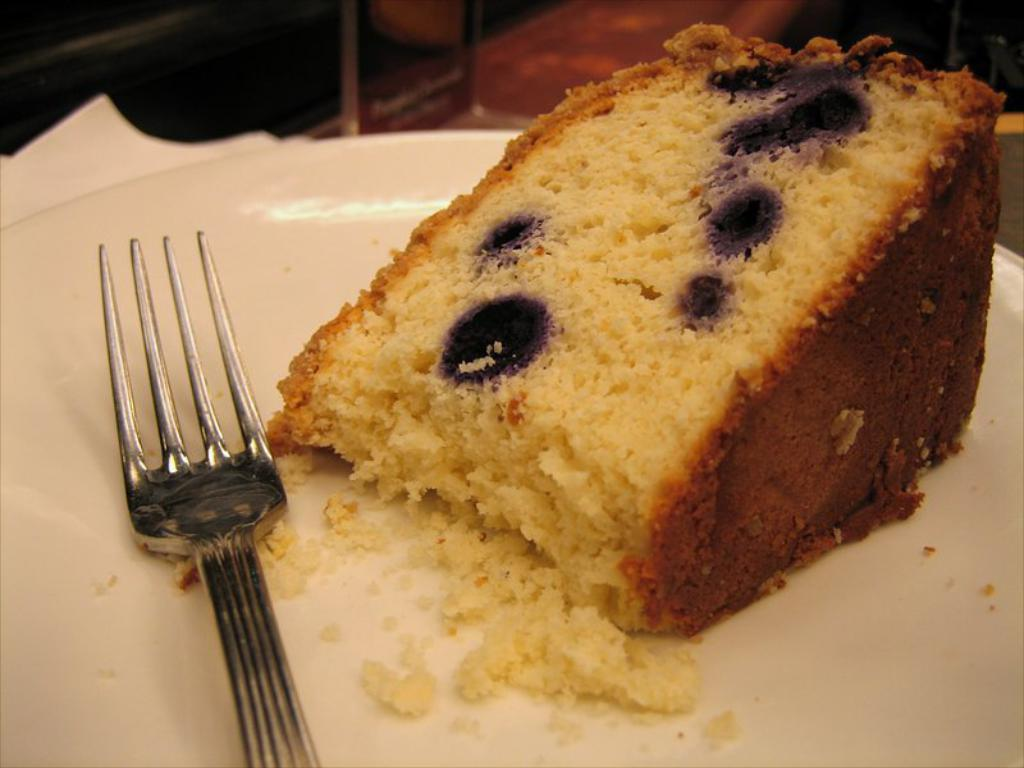What object is present on the plate in the image? There is a fork on the plate in the image. What else can be seen on the plate besides the fork? There is food on the plate in the image. What is the color of the plate? The plate is white. What can be seen behind the plate in the image? There are items visible behind the plate in the image. How many pins are holding the food on the plate in the image? There are no pins present in the image; the food is held on the plate by the fork. Can you see a bucket in the image? There is no bucket present in the image. 